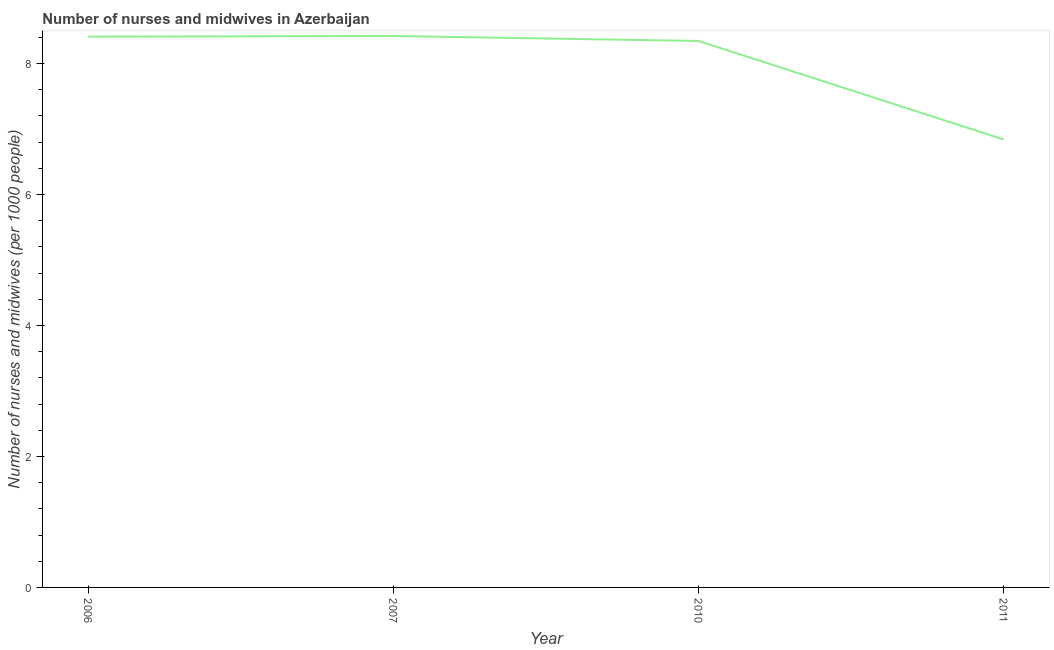What is the number of nurses and midwives in 2011?
Keep it short and to the point. 6.84. Across all years, what is the maximum number of nurses and midwives?
Ensure brevity in your answer.  8.42. Across all years, what is the minimum number of nurses and midwives?
Your answer should be compact. 6.84. In which year was the number of nurses and midwives maximum?
Provide a short and direct response. 2007. In which year was the number of nurses and midwives minimum?
Provide a short and direct response. 2011. What is the sum of the number of nurses and midwives?
Offer a terse response. 32.01. What is the difference between the number of nurses and midwives in 2007 and 2011?
Give a very brief answer. 1.58. What is the average number of nurses and midwives per year?
Provide a short and direct response. 8. What is the median number of nurses and midwives?
Ensure brevity in your answer.  8.38. What is the ratio of the number of nurses and midwives in 2010 to that in 2011?
Give a very brief answer. 1.22. Is the difference between the number of nurses and midwives in 2006 and 2007 greater than the difference between any two years?
Offer a terse response. No. What is the difference between the highest and the second highest number of nurses and midwives?
Your answer should be compact. 0.01. Is the sum of the number of nurses and midwives in 2007 and 2011 greater than the maximum number of nurses and midwives across all years?
Your answer should be very brief. Yes. What is the difference between the highest and the lowest number of nurses and midwives?
Ensure brevity in your answer.  1.58. How many years are there in the graph?
Offer a very short reply. 4. What is the difference between two consecutive major ticks on the Y-axis?
Offer a very short reply. 2. Are the values on the major ticks of Y-axis written in scientific E-notation?
Your answer should be compact. No. What is the title of the graph?
Ensure brevity in your answer.  Number of nurses and midwives in Azerbaijan. What is the label or title of the Y-axis?
Offer a terse response. Number of nurses and midwives (per 1000 people). What is the Number of nurses and midwives (per 1000 people) of 2006?
Keep it short and to the point. 8.41. What is the Number of nurses and midwives (per 1000 people) of 2007?
Make the answer very short. 8.42. What is the Number of nurses and midwives (per 1000 people) of 2010?
Keep it short and to the point. 8.34. What is the Number of nurses and midwives (per 1000 people) of 2011?
Offer a very short reply. 6.84. What is the difference between the Number of nurses and midwives (per 1000 people) in 2006 and 2007?
Ensure brevity in your answer.  -0.01. What is the difference between the Number of nurses and midwives (per 1000 people) in 2006 and 2010?
Make the answer very short. 0.07. What is the difference between the Number of nurses and midwives (per 1000 people) in 2006 and 2011?
Ensure brevity in your answer.  1.57. What is the difference between the Number of nurses and midwives (per 1000 people) in 2007 and 2010?
Offer a very short reply. 0.08. What is the difference between the Number of nurses and midwives (per 1000 people) in 2007 and 2011?
Make the answer very short. 1.58. What is the difference between the Number of nurses and midwives (per 1000 people) in 2010 and 2011?
Provide a short and direct response. 1.5. What is the ratio of the Number of nurses and midwives (per 1000 people) in 2006 to that in 2007?
Your answer should be very brief. 1. What is the ratio of the Number of nurses and midwives (per 1000 people) in 2006 to that in 2010?
Provide a short and direct response. 1.01. What is the ratio of the Number of nurses and midwives (per 1000 people) in 2006 to that in 2011?
Ensure brevity in your answer.  1.23. What is the ratio of the Number of nurses and midwives (per 1000 people) in 2007 to that in 2011?
Your response must be concise. 1.23. What is the ratio of the Number of nurses and midwives (per 1000 people) in 2010 to that in 2011?
Make the answer very short. 1.22. 